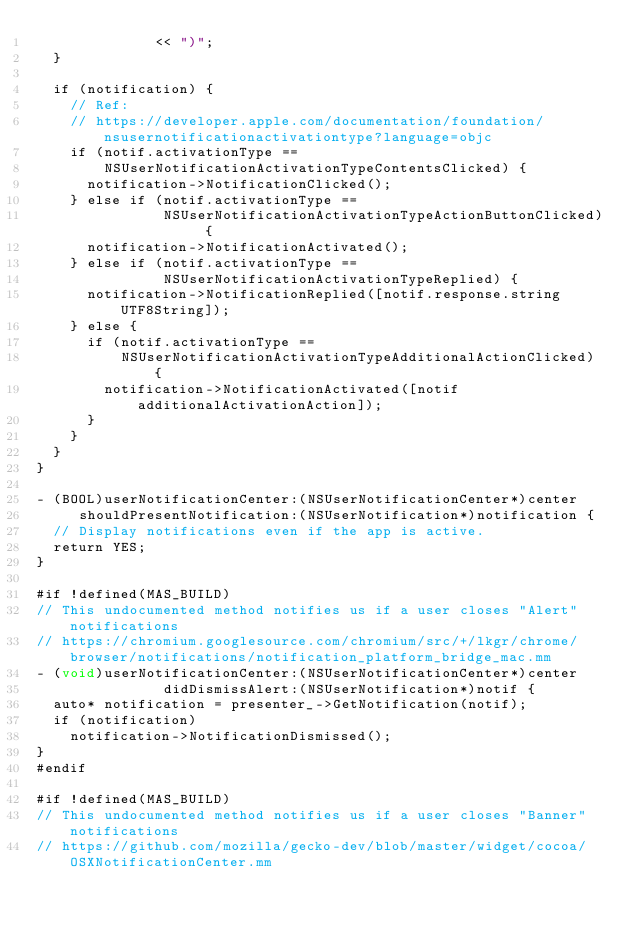Convert code to text. <code><loc_0><loc_0><loc_500><loc_500><_ObjectiveC_>              << ")";
  }

  if (notification) {
    // Ref:
    // https://developer.apple.com/documentation/foundation/nsusernotificationactivationtype?language=objc
    if (notif.activationType ==
        NSUserNotificationActivationTypeContentsClicked) {
      notification->NotificationClicked();
    } else if (notif.activationType ==
               NSUserNotificationActivationTypeActionButtonClicked) {
      notification->NotificationActivated();
    } else if (notif.activationType ==
               NSUserNotificationActivationTypeReplied) {
      notification->NotificationReplied([notif.response.string UTF8String]);
    } else {
      if (notif.activationType ==
          NSUserNotificationActivationTypeAdditionalActionClicked) {
        notification->NotificationActivated([notif additionalActivationAction]);
      }
    }
  }
}

- (BOOL)userNotificationCenter:(NSUserNotificationCenter*)center
     shouldPresentNotification:(NSUserNotification*)notification {
  // Display notifications even if the app is active.
  return YES;
}

#if !defined(MAS_BUILD)
// This undocumented method notifies us if a user closes "Alert" notifications
// https://chromium.googlesource.com/chromium/src/+/lkgr/chrome/browser/notifications/notification_platform_bridge_mac.mm
- (void)userNotificationCenter:(NSUserNotificationCenter*)center
               didDismissAlert:(NSUserNotification*)notif {
  auto* notification = presenter_->GetNotification(notif);
  if (notification)
    notification->NotificationDismissed();
}
#endif

#if !defined(MAS_BUILD)
// This undocumented method notifies us if a user closes "Banner" notifications
// https://github.com/mozilla/gecko-dev/blob/master/widget/cocoa/OSXNotificationCenter.mm</code> 